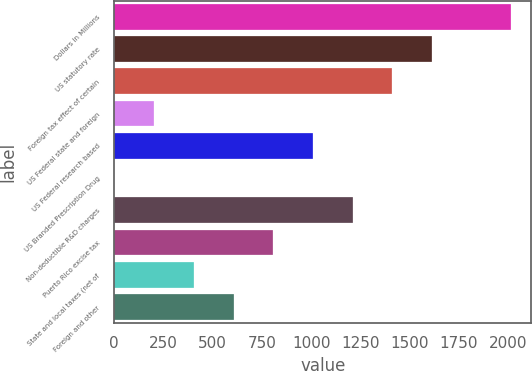Convert chart to OTSL. <chart><loc_0><loc_0><loc_500><loc_500><bar_chart><fcel>Dollars in Millions<fcel>US statutory rate<fcel>Foreign tax effect of certain<fcel>US Federal state and foreign<fcel>US Federal research based<fcel>US Branded Prescription Drug<fcel>Non-deductible R&D charges<fcel>Puerto Rico excise tax<fcel>State and local taxes (net of<fcel>Foreign and other<nl><fcel>2017<fcel>1613.8<fcel>1412.2<fcel>202.6<fcel>1009<fcel>1<fcel>1210.6<fcel>807.4<fcel>404.2<fcel>605.8<nl></chart> 